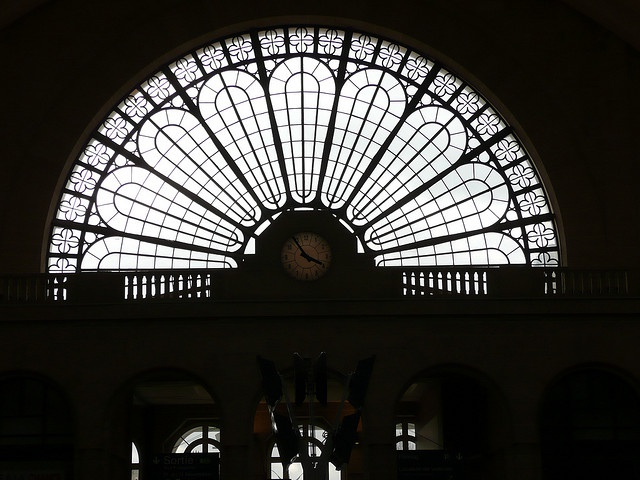Describe the objects in this image and their specific colors. I can see a clock in black tones in this image. 